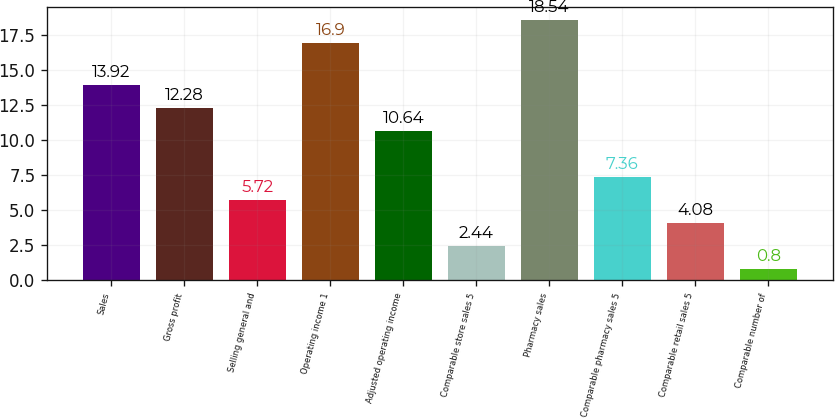<chart> <loc_0><loc_0><loc_500><loc_500><bar_chart><fcel>Sales<fcel>Gross profit<fcel>Selling general and<fcel>Operating income 1<fcel>Adjusted operating income<fcel>Comparable store sales 5<fcel>Pharmacy sales<fcel>Comparable pharmacy sales 5<fcel>Comparable retail sales 5<fcel>Comparable number of<nl><fcel>13.92<fcel>12.28<fcel>5.72<fcel>16.9<fcel>10.64<fcel>2.44<fcel>18.54<fcel>7.36<fcel>4.08<fcel>0.8<nl></chart> 